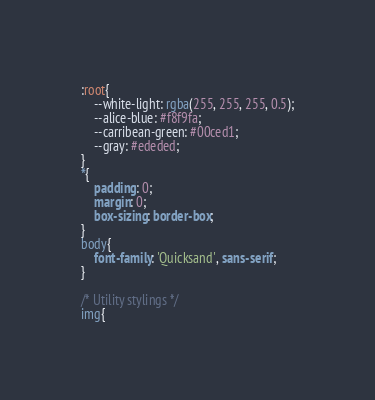<code> <loc_0><loc_0><loc_500><loc_500><_CSS_>

:root{
    --white-light: rgba(255, 255, 255, 0.5);
    --alice-blue: #f8f9fa;
    --carribean-green: #00ced1;
    --gray: #ededed;
}
*{
    padding: 0;
    margin: 0;
    box-sizing: border-box;
}
body{
    font-family: 'Quicksand', sans-serif;
}

/* Utility stylings */
img{</code> 